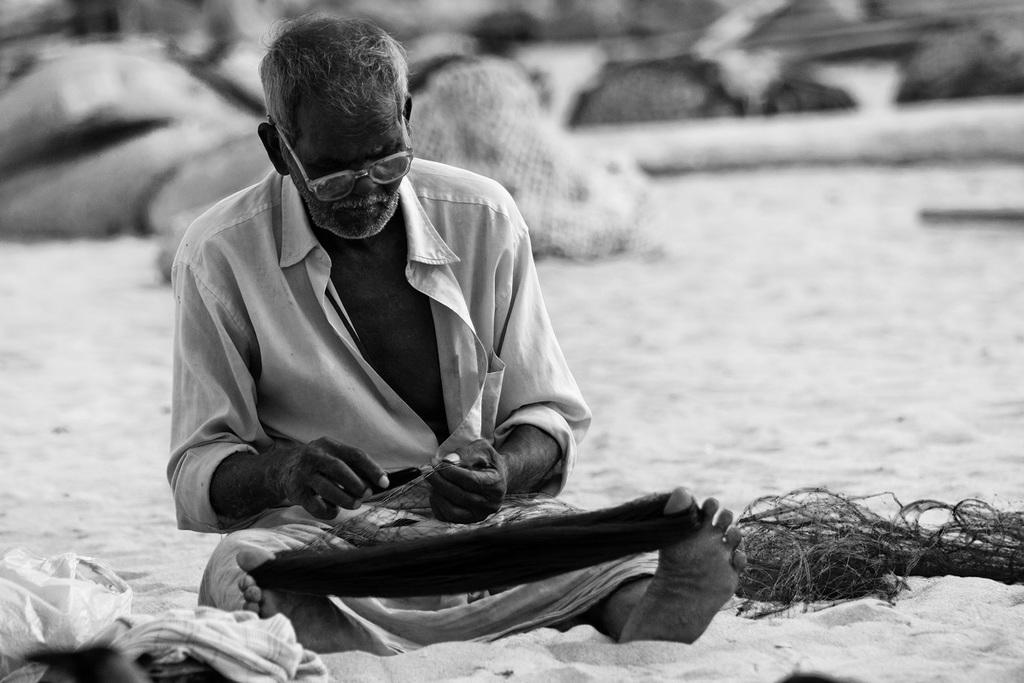Who is present in the image? There is a man in the picture. What is the man doing in the image? The man is seated. What accessory is the man wearing in the image? The man is wearing spectacles. What objects can be seen in the image besides the man? There are ropes visible in the picture. What is the color scheme of the image? The photograph is black and white. What type of skirt is the man wearing in the image? The man is not wearing a skirt in the image; he is wearing spectacles. Can you describe the orange color in the image? There is no orange color present in the black and white image. 